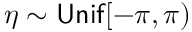Convert formula to latex. <formula><loc_0><loc_0><loc_500><loc_500>\eta \sim U n i f [ - \pi , \pi )</formula> 